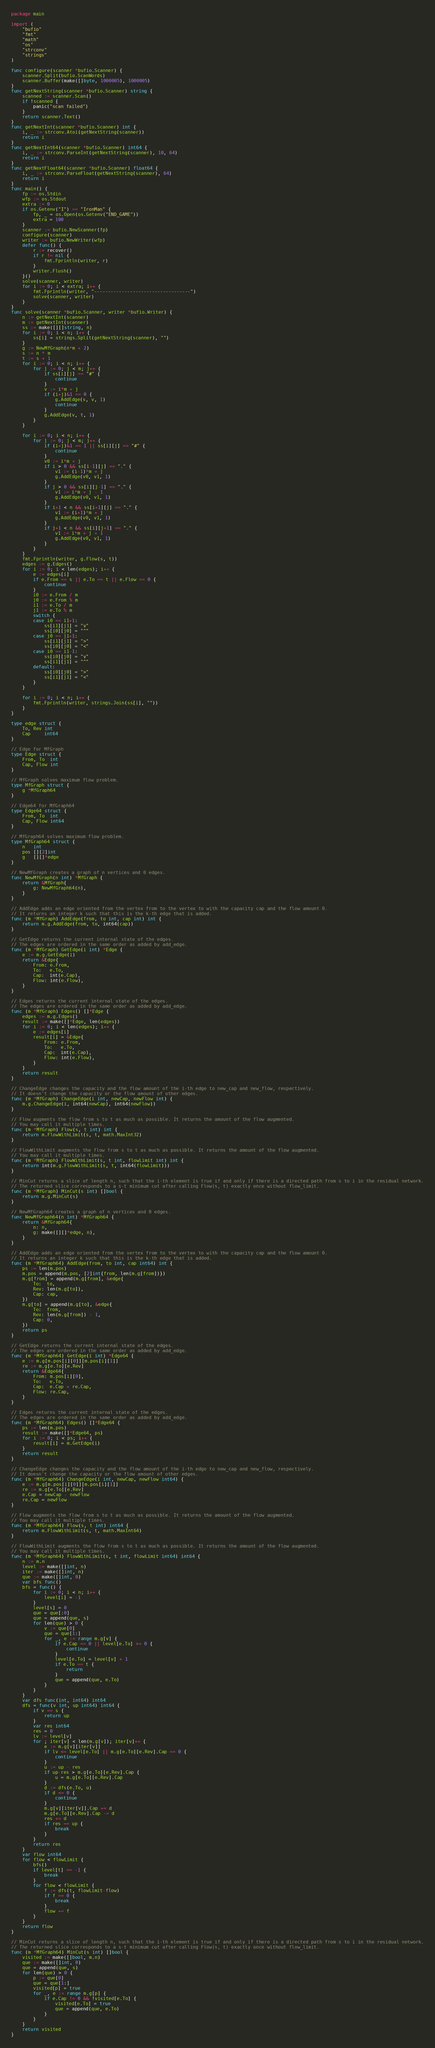<code> <loc_0><loc_0><loc_500><loc_500><_Go_>package main

import (
	"bufio"
	"fmt"
	"math"
	"os"
	"strconv"
	"strings"
)

func configure(scanner *bufio.Scanner) {
	scanner.Split(bufio.ScanWords)
	scanner.Buffer(make([]byte, 1000005), 1000005)
}
func getNextString(scanner *bufio.Scanner) string {
	scanned := scanner.Scan()
	if !scanned {
		panic("scan failed")
	}
	return scanner.Text()
}
func getNextInt(scanner *bufio.Scanner) int {
	i, _ := strconv.Atoi(getNextString(scanner))
	return i
}
func getNextInt64(scanner *bufio.Scanner) int64 {
	i, _ := strconv.ParseInt(getNextString(scanner), 10, 64)
	return i
}
func getNextFloat64(scanner *bufio.Scanner) float64 {
	i, _ := strconv.ParseFloat(getNextString(scanner), 64)
	return i
}
func main() {
	fp := os.Stdin
	wfp := os.Stdout
	extra := 0
	if os.Getenv("I") == "IronMan" {
		fp, _ = os.Open(os.Getenv("END_GAME"))
		extra = 100
	}
	scanner := bufio.NewScanner(fp)
	configure(scanner)
	writer := bufio.NewWriter(wfp)
	defer func() {
		r := recover()
		if r != nil {
			fmt.Fprintln(writer, r)
		}
		writer.Flush()
	}()
	solve(scanner, writer)
	for i := 0; i < extra; i++ {
		fmt.Fprintln(writer, "-----------------------------------")
		solve(scanner, writer)
	}
}
func solve(scanner *bufio.Scanner, writer *bufio.Writer) {
	n := getNextInt(scanner)
	m := getNextInt(scanner)
	ss := make([][]string, n)
	for i := 0; i < n; i++ {
		ss[i] = strings.Split(getNextString(scanner), "")
	}
	g := NewMfGraph(n*m + 2)
	s := n * m
	t := s + 1
	for i := 0; i < n; i++ {
		for j := 0; j < m; j++ {
			if ss[i][j] == "#" {
				continue
			}
			v := i*m + j
			if (i+j)&1 == 0 {
				g.AddEdge(s, v, 1)
				continue
			}
			g.AddEdge(v, t, 1)
		}
	}

	for i := 0; i < n; i++ {
		for j := 0; j < m; j++ {
			if (i+j)&1 == 1 || ss[i][j] == "#" {
				continue
			}
			v0 := i*m + j
			if i > 0 && ss[i-1][j] == "." {
				v1 := (i-1)*m + j
				g.AddEdge(v0, v1, 1)
			}
			if j > 0 && ss[i][j-1] == "." {
				v1 := i*m + j - 1
				g.AddEdge(v0, v1, 1)
			}
			if i+1 < n && ss[i+1][j] == "." {
				v1 := (i+1)*m + j
				g.AddEdge(v0, v1, 1)
			}
			if j+1 < n && ss[i][j+1] == "." {
				v1 := i*m + j + 1
				g.AddEdge(v0, v1, 1)
			}
		}
	}
	fmt.Fprintln(writer, g.Flow(s, t))
	edges := g.Edges()
	for i := 0; i < len(edges); i++ {
		e := edges[i]
		if e.From == s || e.To == t || e.Flow == 0 {
			continue
		}
		i0 := e.From / m
		j0 := e.From % m
		i1 := e.To / m
		j1 := e.To % m
		switch {
		case i0 == i1+1:
			ss[i1][j1] = "v"
			ss[i0][j0] = "^"
		case j0 == j1+1:
			ss[i1][j1] = ">"
			ss[i0][j0] = "<"
		case i0 == i1-1:
			ss[i0][j0] = "v"
			ss[i1][j1] = "^"
		default:
			ss[i0][j0] = ">"
			ss[i1][j1] = "<"
		}
	}

	for i := 0; i < n; i++ {
		fmt.Fprintln(writer, strings.Join(ss[i], ""))
	}
}

type edge struct {
	To, Rev int
	Cap     int64
}

// Edge for MfGraph
type Edge struct {
	From, To  int
	Cap, Flow int
}

// MfGraph solves maximum flow problem.
type MfGraph struct {
	g *MfGraph64
}

// Edge64 for MfGraph64
type Edge64 struct {
	From, To  int
	Cap, Flow int64
}

// MfGraph64 solves maximum flow problem.
type MfGraph64 struct {
	n   int
	pos [][2]int
	g   [][]*edge
}

// NewMfGraph creates a graph of n vertices and 0 edges.
func NewMfGraph(n int) *MfGraph {
	return &MfGraph{
		g: NewMfGraph64(n),
	}
}

// AddEdge adds an edge oriented from the vertex from to the vertex to with the capacity cap and the flow amount 0.
// It returns an integer k such that this is the k-th edge that is added.
func (m *MfGraph) AddEdge(from, to int, cap int) int {
	return m.g.AddEdge(from, to, int64(cap))
}

// GetEdge returns the current internal state of the edges.
// The edges are ordered in the same order as added by add_edge.
func (m *MfGraph) GetEdge(i int) *Edge {
	e := m.g.GetEdge(i)
	return &Edge{
		From: e.From,
		To:   e.To,
		Cap:  int(e.Cap),
		Flow: int(e.Flow),
	}
}

// Edges returns the current internal state of the edges.
// The edges are ordered in the same order as added by add_edge.
func (m *MfGraph) Edges() []*Edge {
	edges := m.g.Edges()
	result := make([]*Edge, len(edges))
	for i := 0; i < len(edges); i++ {
		e := edges[i]
		result[i] = &Edge{
			From: e.From,
			To:   e.To,
			Cap:  int(e.Cap),
			Flow: int(e.Flow),
		}
	}
	return result
}

// ChangeEdge changes the capacity and the flow amount of the i-th edge to new_cap and new_flow, respectively.
// It doesn't change the capacity or the flow amount of other edges.
func (m *MfGraph) ChangeEdge(i int, newCap, newFlow int) {
	m.g.ChangeEdge(i, int64(newCap), int64(newFlow))
}

// Flow augments the flow from s to t as much as possible. It returns the amount of the flow augmented.
// You may call it multiple times.
func (m *MfGraph) Flow(s, t int) int {
	return m.FlowWithLimit(s, t, math.MaxInt32)
}

// FlowWithLimit augments the flow from s to t as much as possible. It returns the amount of the flow augmented.
// You may call it multiple times.
func (m *MfGraph) FlowWithLimit(s, t int, flowLimit int) int {
	return int(m.g.FlowWithLimit(s, t, int64(flowLimit)))
}

// MinCut returns a slice of length n, such that the i-th element is true if and only if there is a directed path from s to i in the residual network.
// The returned slice corresponds to a s-t minimum cut after calling Flow(s, t) exactly once without flow_limit.
func (m *MfGraph) MinCut(s int) []bool {
	return m.g.MinCut(s)
}

// NewMfGraph64 creates a graph of n vertices and 0 edges.
func NewMfGraph64(n int) *MfGraph64 {
	return &MfGraph64{
		n: n,
		g: make([][]*edge, n),
	}
}

// AddEdge adds an edge oriented from the vertex from to the vertex to with the capacity cap and the flow amount 0.
// It returns an integer k such that this is the k-th edge that is added.
func (m *MfGraph64) AddEdge(from, to int, cap int64) int {
	ps := len(m.pos)
	m.pos = append(m.pos, [2]int{from, len(m.g[from])})
	m.g[from] = append(m.g[from], &edge{
		To:  to,
		Rev: len(m.g[to]),
		Cap: cap,
	})
	m.g[to] = append(m.g[to], &edge{
		To:  from,
		Rev: len(m.g[from]) - 1,
		Cap: 0,
	})
	return ps
}

// GetEdge returns the current internal state of the edges.
// The edges are ordered in the same order as added by add_edge.
func (m *MfGraph64) GetEdge(i int) *Edge64 {
	e := m.g[m.pos[i][0]][m.pos[i][1]]
	re := m.g[e.To][e.Rev]
	return &Edge64{
		From: m.pos[i][0],
		To:   e.To,
		Cap:  e.Cap + re.Cap,
		Flow: re.Cap,
	}
}

// Edges returns the current internal state of the edges.
// The edges are ordered in the same order as added by add_edge.
func (m *MfGraph64) Edges() []*Edge64 {
	ps := len(m.pos)
	result := make([]*Edge64, ps)
	for i := 0; i < ps; i++ {
		result[i] = m.GetEdge(i)
	}
	return result
}

// ChangeEdge changes the capacity and the flow amount of the i-th edge to new_cap and new_flow, respectively.
// It doesn't change the capacity or the flow amount of other edges.
func (m *MfGraph64) ChangeEdge(i int, newCap, newFlow int64) {
	e := m.g[m.pos[i][0]][m.pos[i][1]]
	re := m.g[e.To][e.Rev]
	e.Cap = newCap - newFlow
	re.Cap = newFlow
}

// Flow augments the flow from s to t as much as possible. It returns the amount of the flow augmented.
// You may call it multiple times.
func (m *MfGraph64) Flow(s, t int) int64 {
	return m.FlowWithLimit(s, t, math.MaxInt64)
}

// FlowWithLimit augments the flow from s to t as much as possible. It returns the amount of the flow augmented.
// You may call it multiple times.
func (m *MfGraph64) FlowWithLimit(s, t int, flowLimit int64) int64 {
	n := m.n
	level := make([]int, n)
	iter := make([]int, n)
	que := make([]int, 0)
	var bfs func()
	bfs = func() {
		for i := 0; i < n; i++ {
			level[i] = -1
		}
		level[s] = 0
		que = que[:0]
		que = append(que, s)
		for len(que) > 0 {
			v := que[0]
			que = que[1:]
			for _, e := range m.g[v] {
				if e.Cap == 0 || level[e.To] >= 0 {
					continue
				}
				level[e.To] = level[v] + 1
				if e.To == t {
					return
				}
				que = append(que, e.To)
			}
		}
	}
	var dfs func(int, int64) int64
	dfs = func(v int, up int64) int64 {
		if v == s {
			return up
		}
		var res int64
		res = 0
		lv := level[v]
		for ; iter[v] < len(m.g[v]); iter[v]++ {
			e := m.g[v][iter[v]]
			if lv <= level[e.To] || m.g[e.To][e.Rev].Cap == 0 {
				continue
			}
			u := up - res
			if up-res > m.g[e.To][e.Rev].Cap {
				u = m.g[e.To][e.Rev].Cap
			}
			d := dfs(e.To, u)
			if d <= 0 {
				continue
			}
			m.g[v][iter[v]].Cap += d
			m.g[e.To][e.Rev].Cap -= d
			res += d
			if res == up {
				break
			}
		}
		return res
	}
	var flow int64
	for flow < flowLimit {
		bfs()
		if level[t] == -1 {
			break
		}
		for flow < flowLimit {
			f := dfs(t, flowLimit-flow)
			if f == 0 {
				break
			}
			flow += f
		}
	}
	return flow
}

// MinCut returns a slice of length n, such that the i-th element is true if and only if there is a directed path from s to i in the residual network.
// The returned slice corresponds to a s-t minimum cut after calling Flow(s, t) exactly once without flow_limit.
func (m *MfGraph64) MinCut(s int) []bool {
	visited := make([]bool, m.n)
	que := make([]int, 0)
	que = append(que, s)
	for len(que) > 0 {
		p := que[0]
		que = que[1:]
		visited[p] = true
		for _, e := range m.g[p] {
			if e.Cap != 0 && !visited[e.To] {
				visited[e.To] = true
				que = append(que, e.To)
			}
		}
	}
	return visited
}
</code> 